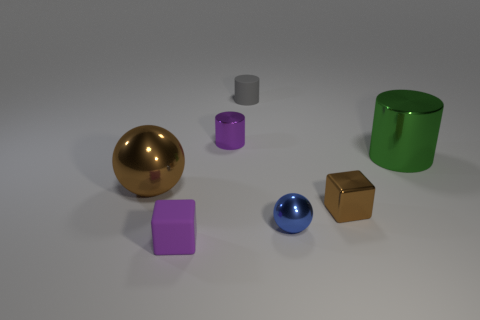What shapes and colors are represented in the image? The image showcases a variety of geometric shapes including a sphere, a cube, a cylinder, and a couple of rectangular prisms. There's a range of colors as well: gold, silver, green, purple, and blue. 